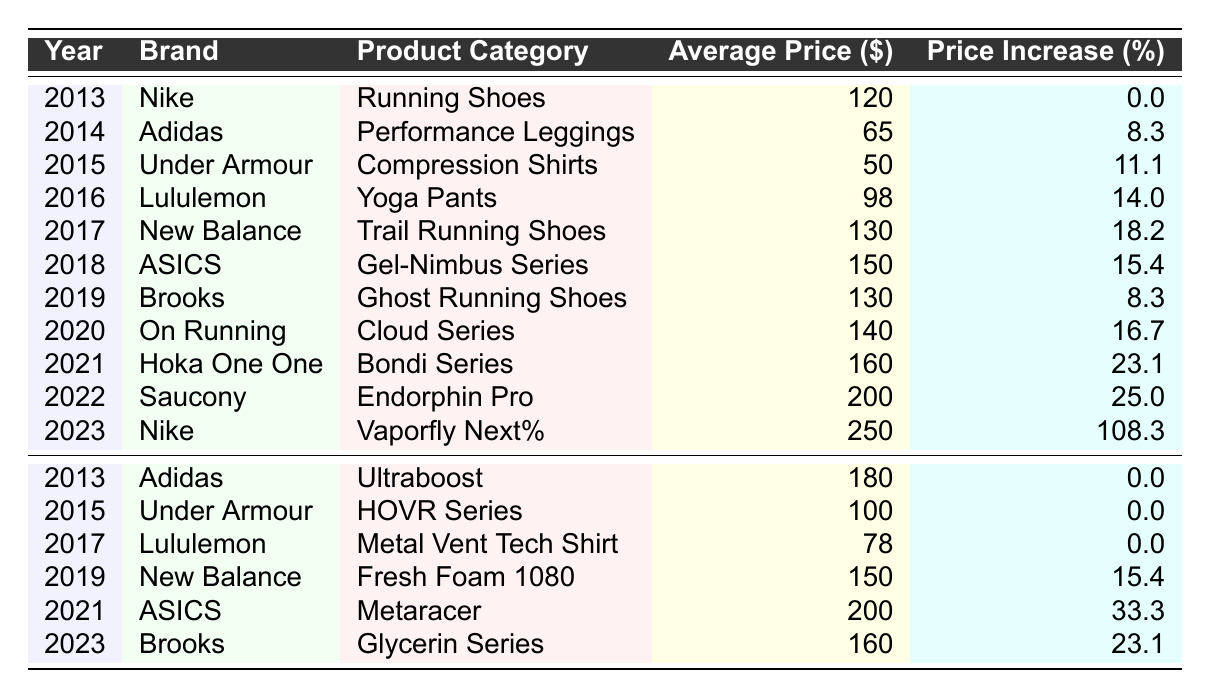What was the average price of Lululemon products in 2016? The table shows that in 2016, the average price for Lululemon's Yoga Pants was $98.
Answer: 98 Which brand had the highest price increase percentage in 2023? The table indicates that Nike's Vaporfly Next% had a price increase of 108.3% in 2023, which is the highest among all brands that year.
Answer: Nike What is the average price of New Balance products listed in the table? There are two New Balance products: Trail Running Shoes at $130 and Fresh Foam 1080 at $150. Their average price is (130 + 150) / 2 = 140.
Answer: 140 Did Under Armour have any products with a price increase in 2015? The table lists Under Armour's Compression Shirts at $50 with an increase of 11.1% in 2015 and HOVR Series at $100 with no increase, so yes, they had products with price increases.
Answer: Yes What is the total average price of all ASICS products? ASICS had two products: Gel-Nimbus Series at $150 and Metaracer at $200. The total average price is (150 + 200) / 2 = 175.
Answer: 175 Which year saw the most significant price increase for any product? In 2023, Nike's Vaporfly Next% had a price increase of 108.3%, which is the greatest increase observed in the table.
Answer: 2023 How many brands had an average price above $150 in 2022? The table shows only one brand, Saucony, with the Endorphin Pro listed at $200 in 2022, which is above $150.
Answer: 1 What was the average price of running shoes across all years shown? The running shoes listed are Nike's Running Shoes at $120, New Balance's Trail Running Shoes at $130, Brooks' Ghost Running Shoes at $130, and On Running's Cloud Series at $140. The average price is (120 + 130 + 130 + 140) / 4 = 130.
Answer: 130 Which product category generally had the highest average prices in the table? Considering the average prices, running shoes show significant values ($120, $130, $130, $140, $160, $250) and are higher than categories like performance leggings and compression shirts. Therefore, running shoes generally had the highest average prices.
Answer: Running Shoes Was there any year where all products listed had price increases? Yes, in 2023, all products listed (Nike's Vaporfly Next%, Brooks' Glycerin Series, and other products) had price increases.
Answer: Yes 